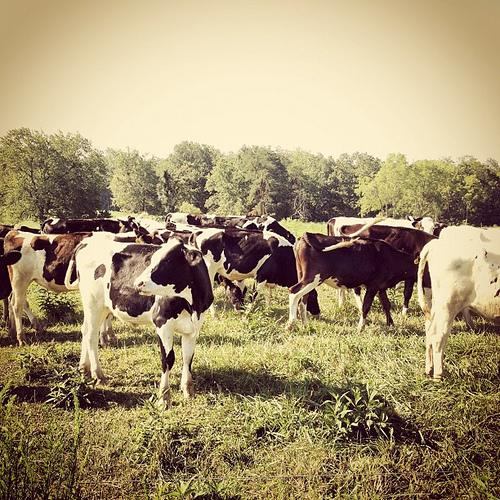Can you identify any specific body parts of cows in the image? If yes, list a few. Yes, in the image you can see cows' heads, tails, legs, rear quarters, ears, and body. How many large black and white cows can be identified in the image? There are five large black and white cows in the image. Describe the state of the cows and what they might be doing collectively in their own words. As a diverse group of cows, we all seem content, mostly standing and facing the same direction, occasionally grazing, wagging our tails, and observing our beautiful surroundings with curiosity. Can you find any plants apart from trees and shrubs in the image? Yes, there are weeds and patches of grass in the image. Describe the colors and the posture of the cows in the image. The cows are black and white, brown and white, and all white, mostly standing and facing in the same direction, some grazing and looking to the left. What are the main objects found in the background of the image? The main objects found in the background of the image are trees and shrubs. What is a distinct feature found on one of the cows? A distinct feature found on one of the cows is an ear tag. Can you infer the cows' environment based on the image? The cows appear to be in a field with grass, weeds, and possibly grazing, indicating that they are on pasture. Choose one cow from the image and describe it in detail. There is a large black and white cow facing right while its head faces left, with a black spot on its body, white rear quarter, and a tail wagging. What keywords would you use to describe the image for product advertisement purposes? Herd of cows, pasture, grazing, peaceful, fresh air, natural, free-range, healthy, countryside, and eco-friendly. Pay attention to the straight tails of the two closest cows. The image mentions wagging tails, not straight tails, so the instruction contradicts the actual information. Imagine a farmer wearing a hat, standing beside the group of cows. There is no mention of a farmer in the image, so adding a person who doesn't exist is misleading. Which of the cows has the largest set of horns? There is no mention of horns on any of the cows in the image, making the instruction misleading. Among the cows, can you see the one with only its front legs visible? There is only mention of back legs of a cow and not front legs, thus misleading the reader towards a wrong observation. Is that a white and black horse standing next to the brown cow? The image contains black and white cows and not horses, so mentioning "horse" is misleading. Do you notice the cow with a blue ear tag? There is mention of an ear tag on the cow, but there is no information about its color. Claiming it as blue is misleading. Look for a patch of grass considerably taller than the rest. There is no mention of a taller grass patch, so this instruction introduces false information. There is one cow lying down. Can you find it? There is no mention of a cow lying down in the image, so asking to find one is misleading. How many cows can you count that are facing completely opposite directions? The image mentions cows facing the same direction, so asking about opposite directions is misleading. Can you spot the dark green tree among the trees in the background? There is no information about the color of the trees, so claiming a tree is dark green is misleading. 